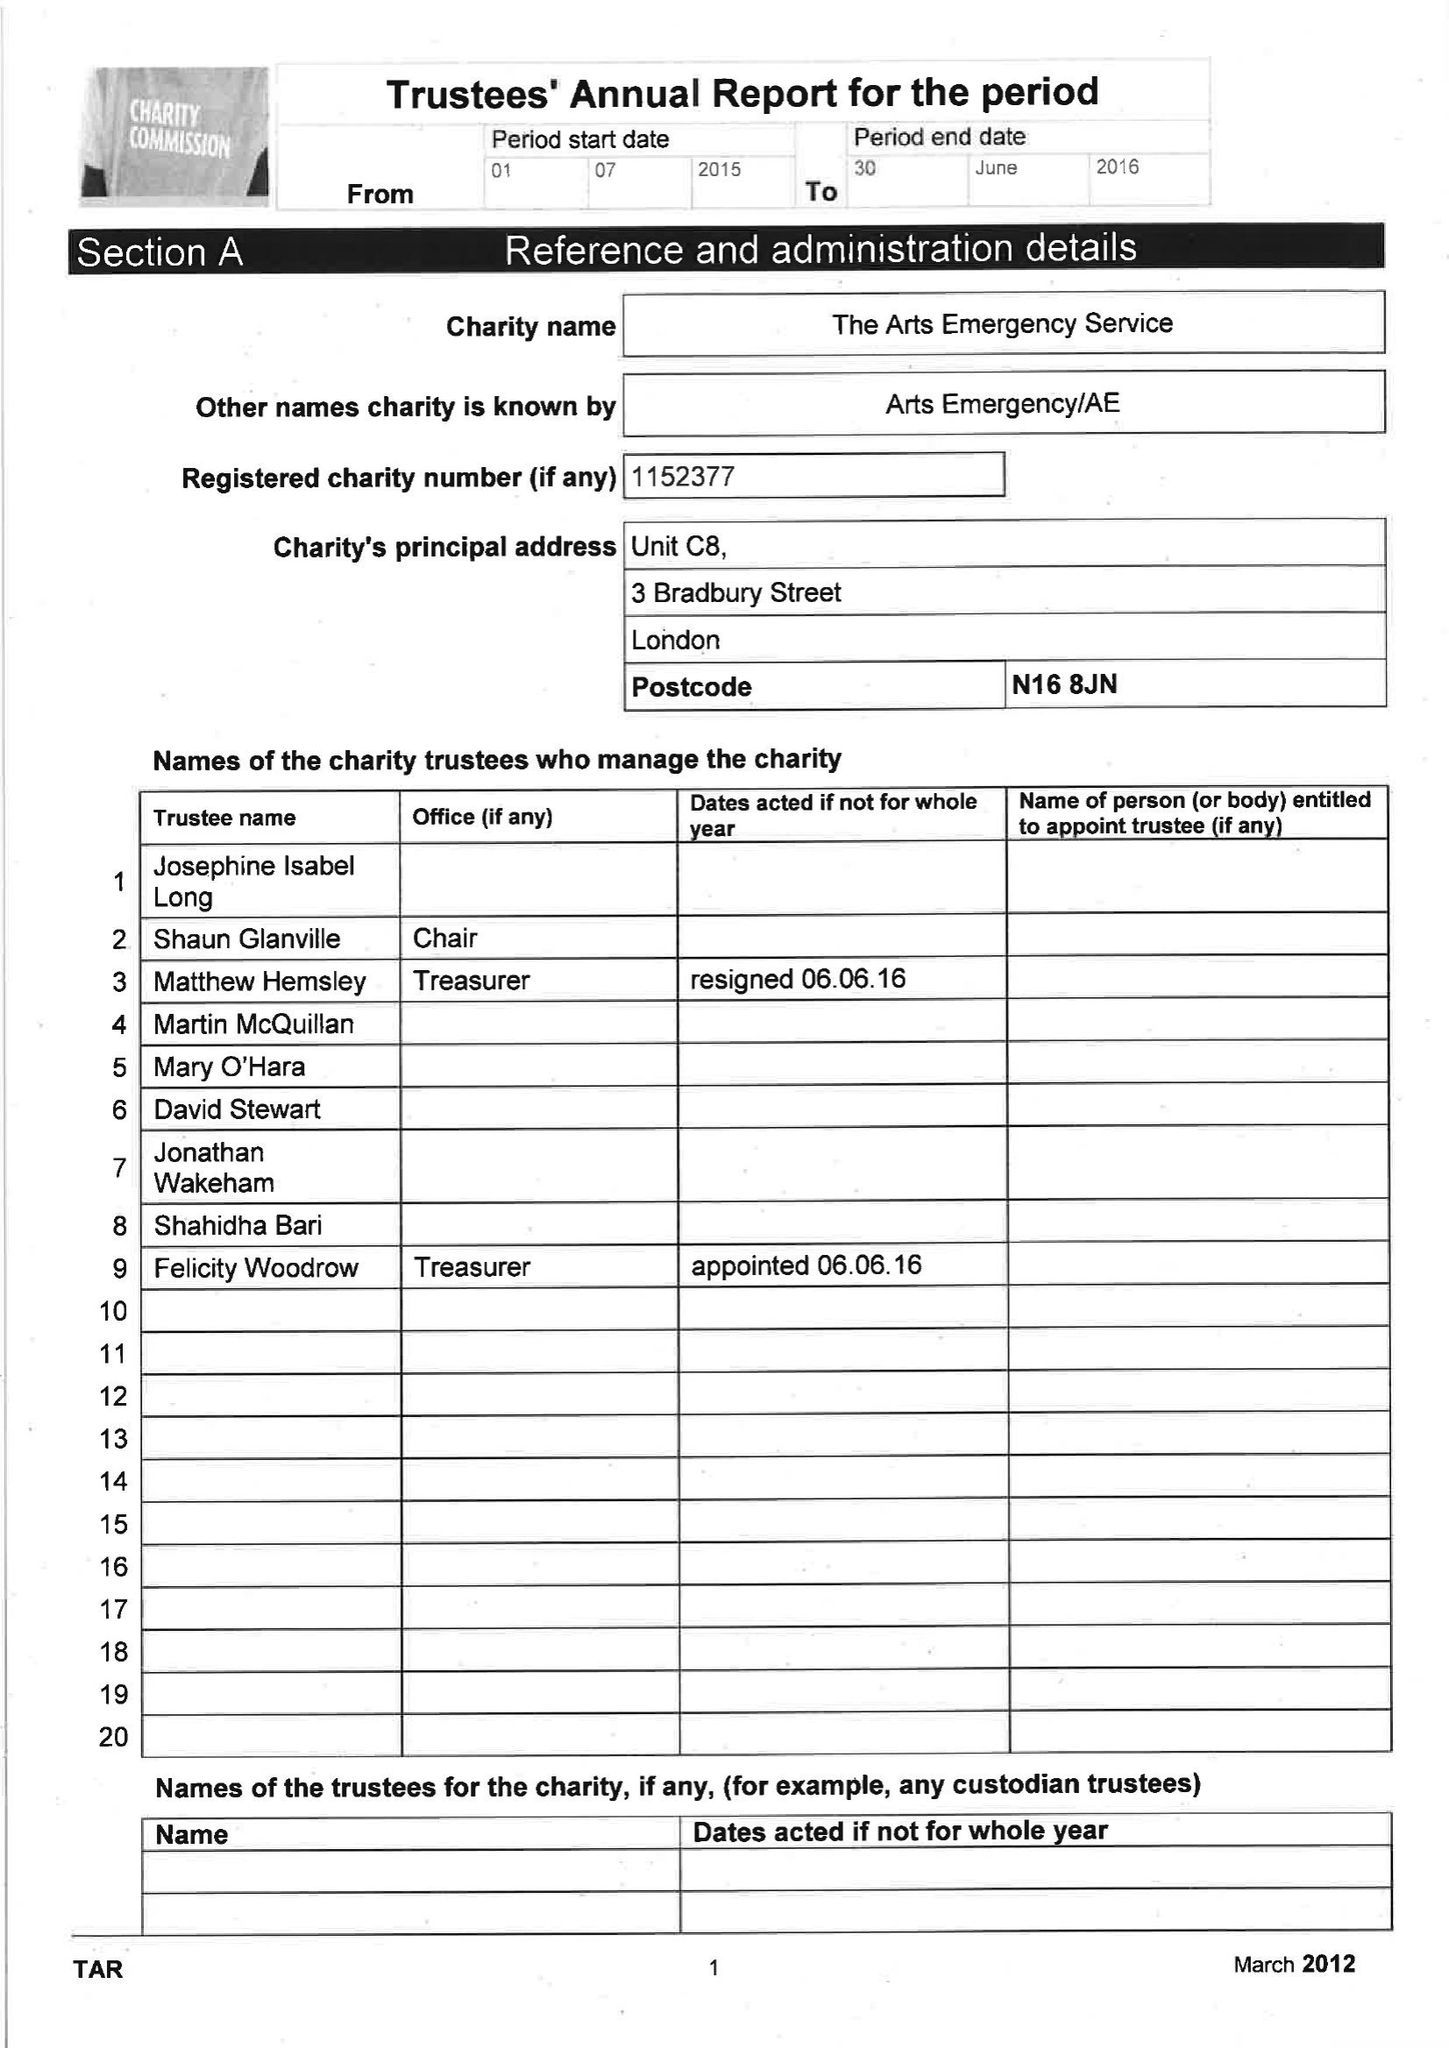What is the value for the income_annually_in_british_pounds?
Answer the question using a single word or phrase. 89175.00 